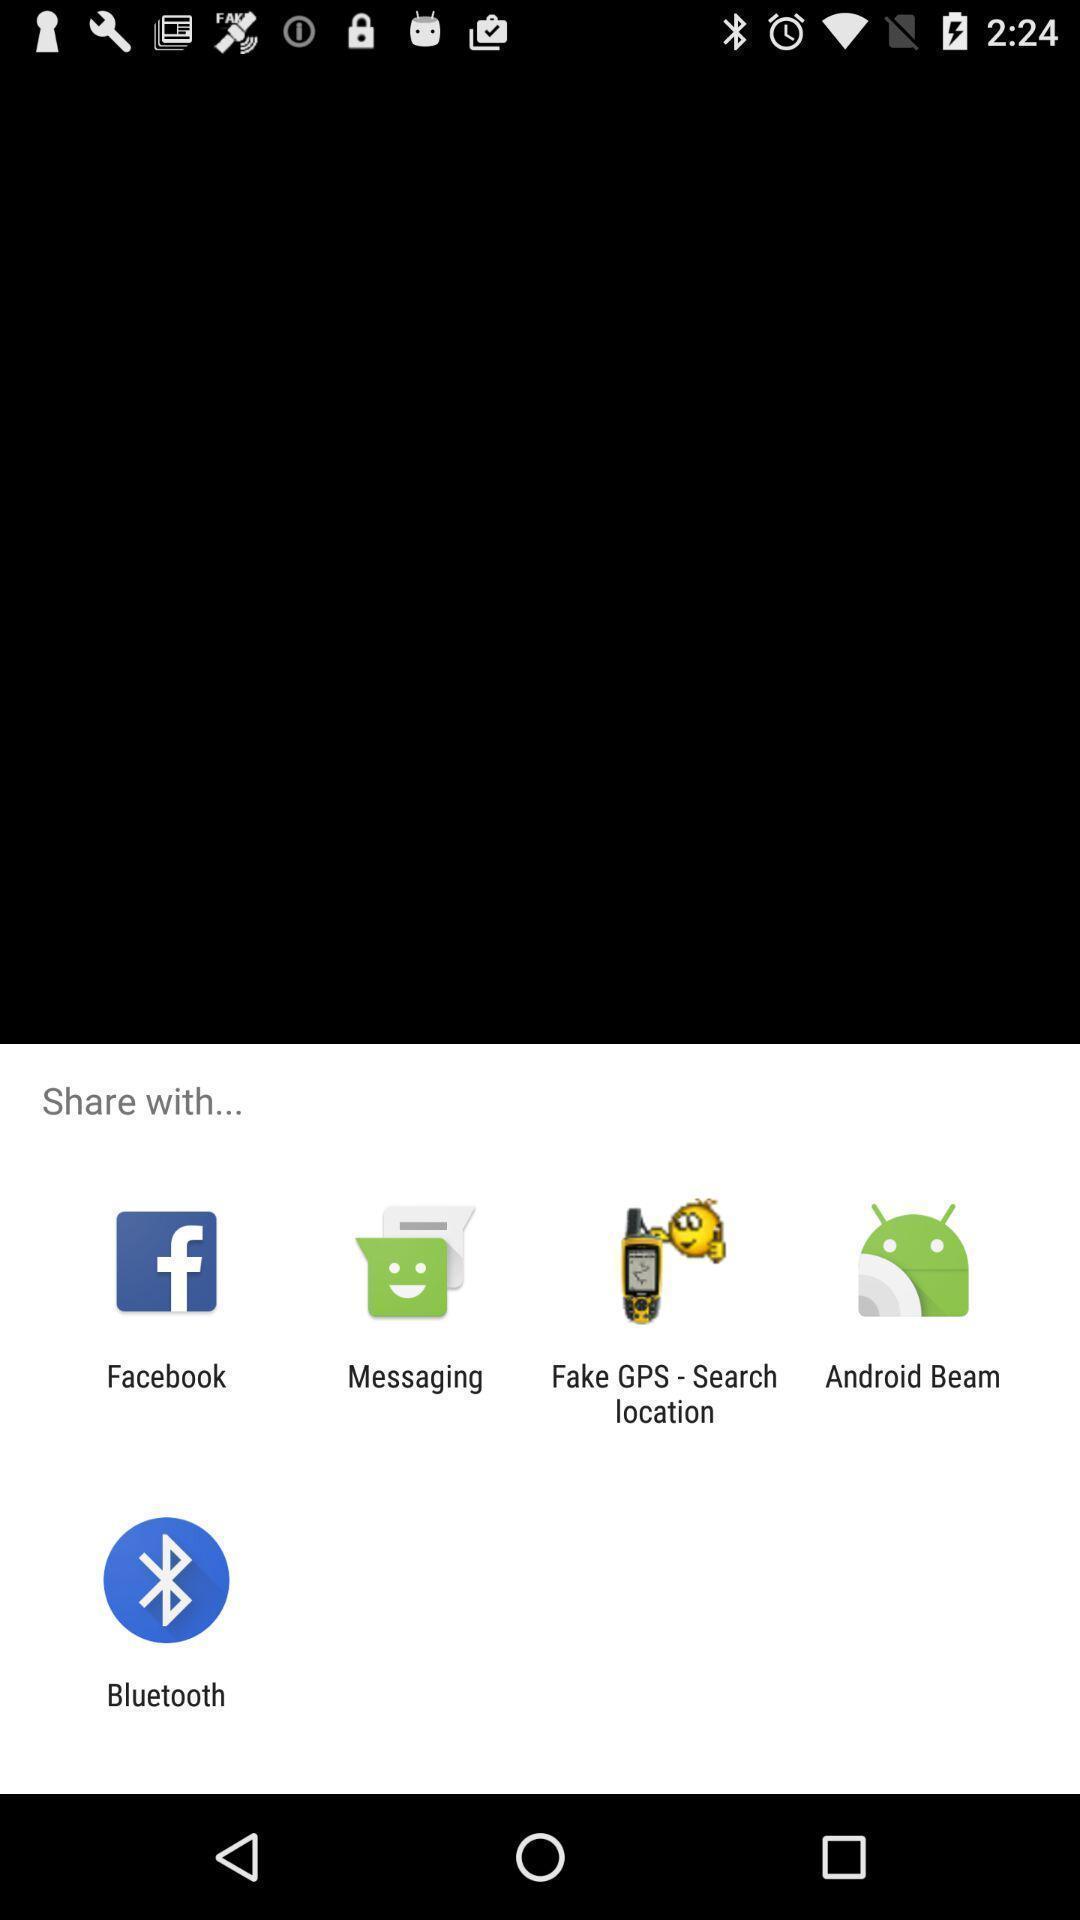Describe the visual elements of this screenshot. Push up message with sharing options. 